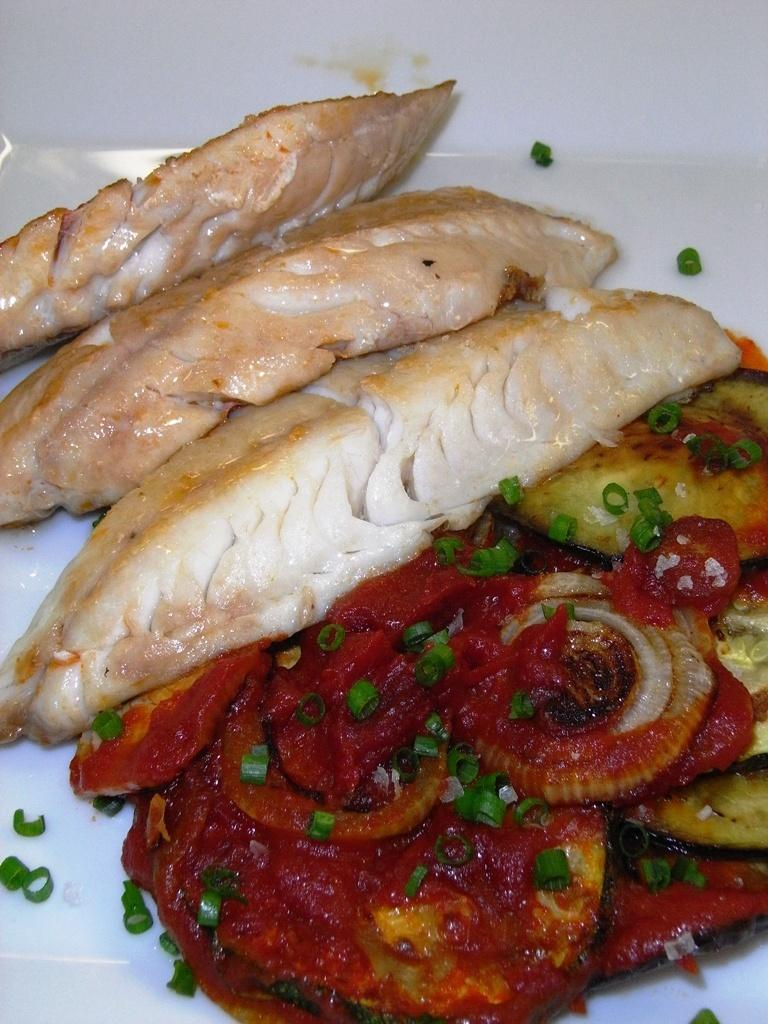What types of food items can be seen on the plate in the image? There are different food items on a plate in the image. What color is the plate? The plate is white. Can you describe the background of the image? There might be a table in the background of the image. What type of steel is visible on the seashore in the image? There is no steel or seashore present in the image; it features a plate of food items. 